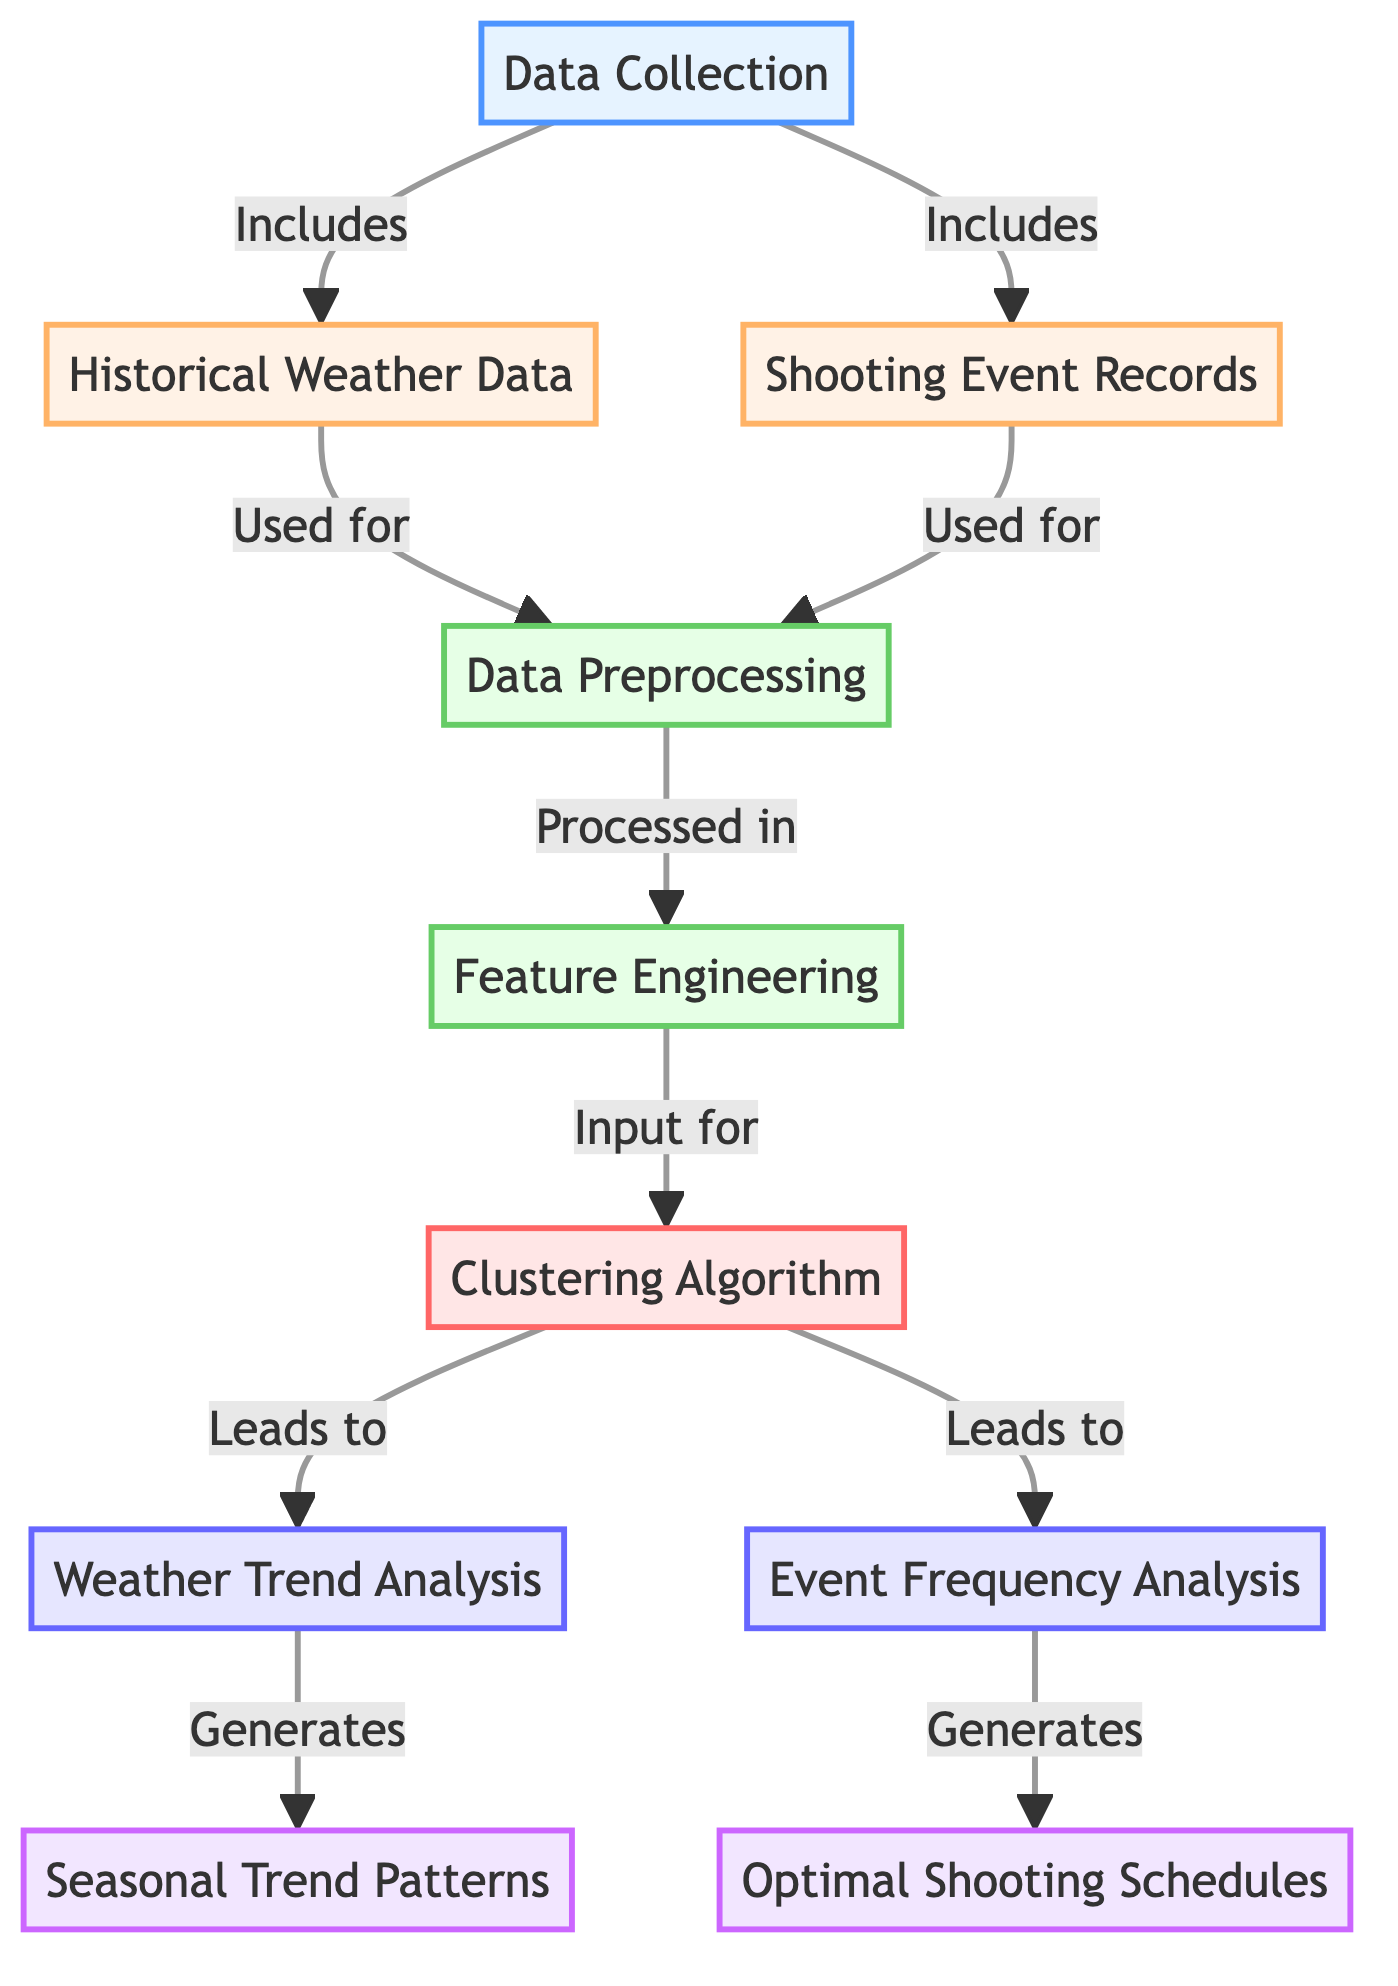What is the first step in this diagram? The diagram starts with "Data Collection," which is the initial step represented by node 1.
Answer: Data Collection How many data sources are included in the data collection step? There are two sources included: "Historical Weather Data" (node 2) and "Shooting Event Records" (node 3), making a total of two sources.
Answer: Two What node processes both historical weather data and shooting event records? The "Data Preprocessing" node (node 4) processes both data sources as indicated by the arrows leading from nodes 2 and 3 to node 4.
Answer: Data Preprocessing Which nodes generate outputs after the clustering algorithm? The outputs generated after the "Clustering Algorithm" (node 6) are "Seasonal Trend Patterns" (node 9) and "Optimal Shooting Schedules" (node 10), indicating there are two outputs.
Answer: Two What is the relationship between feature engineering and the clustering algorithm? The "Feature Engineering" step (node 5) directly feeds input into "Clustering Algorithm" (node 6) as seen from the arrow pointing from node 5 to node 6.
Answer: Input Which analysis focuses specifically on event frequencies? "Event Frequency Analysis" (node 8) is the analysis that specifically focuses on the frequencies of shooting events related to weather conditions.
Answer: Event Frequency Analysis What are the two primary analyses conducted after clustering? The two analyses conducted after clustering are "Weather Trend Analysis" (node 7) and "Event Frequency Analysis" (node 8), showing the subsequent focus areas.
Answer: Weather Trend Analysis and Event Frequency Analysis What is the classification type for the "Feature Engineering" node? The "Feature Engineering" node (node 5) is classified as a process, highlighted by the color fill and the label associated with the class definition for processes.
Answer: Process What is the main purpose of the diagram? The main purpose of the diagram is to analyze seasonal weather trends for outdoor shoots, particularly through clustered event frequency, which helps coordinate safe shooting schedules.
Answer: Analyze seasonal weather trends 